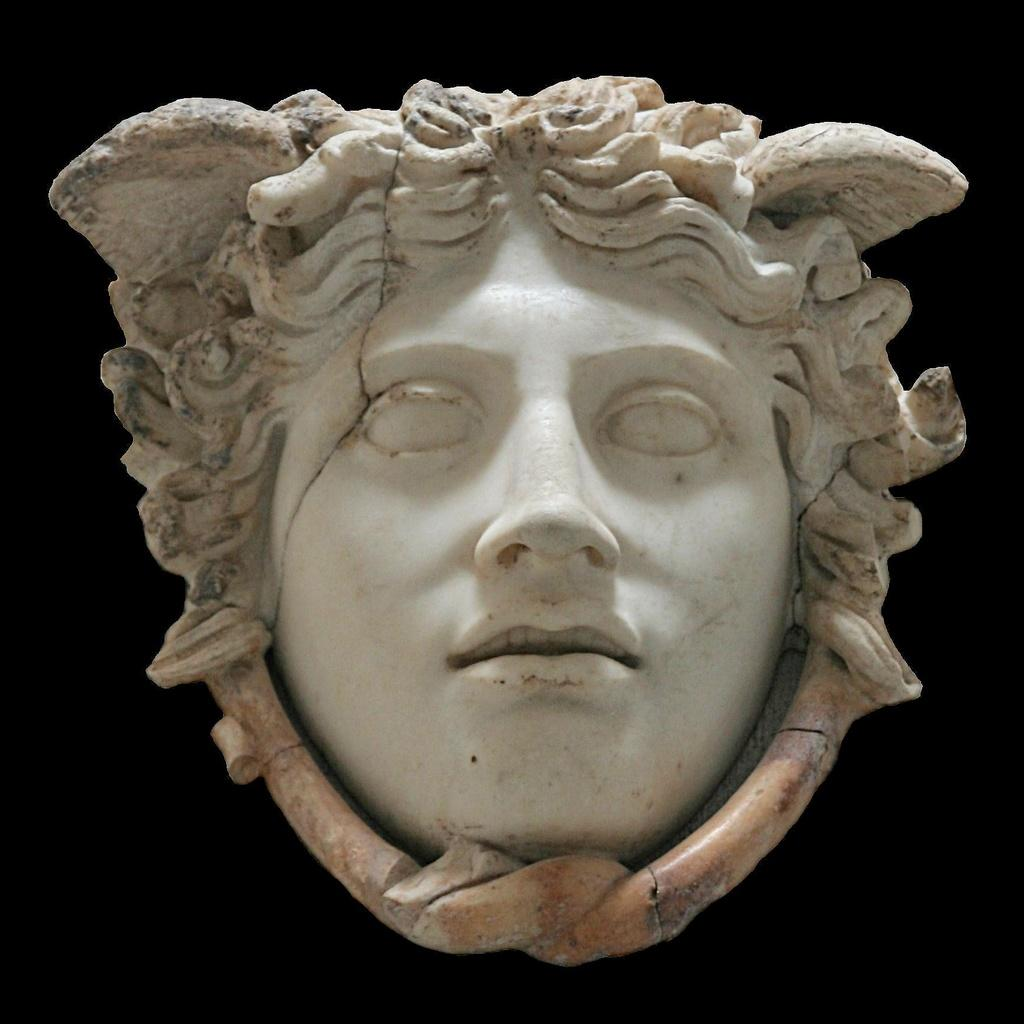What is the main subject of the image? There is a face in the image. What material is the face made of? The face is made of stone. What colors can be seen on the stone face? The stone has white and brown colors. What is the color of the background in the image? The background of the image is dark. What type of coast can be seen in the image? There is no coast present in the image; it features a stone face with a dark background. What action is the face performing in the image? The face is not performing any action in the image; it is a static representation made of stone. 